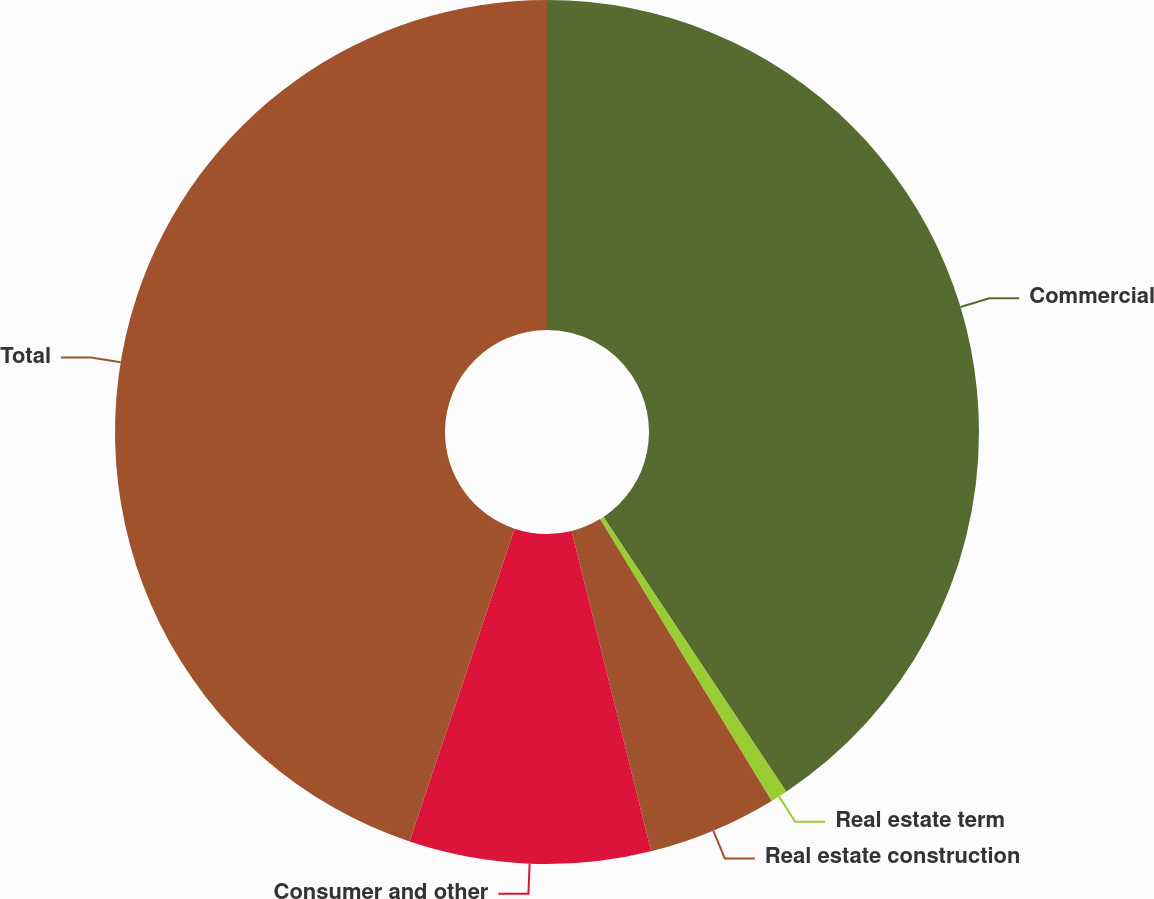Convert chart. <chart><loc_0><loc_0><loc_500><loc_500><pie_chart><fcel>Commercial<fcel>Real estate term<fcel>Real estate construction<fcel>Consumer and other<fcel>Total<nl><fcel>40.66%<fcel>0.64%<fcel>4.83%<fcel>9.03%<fcel>44.85%<nl></chart> 